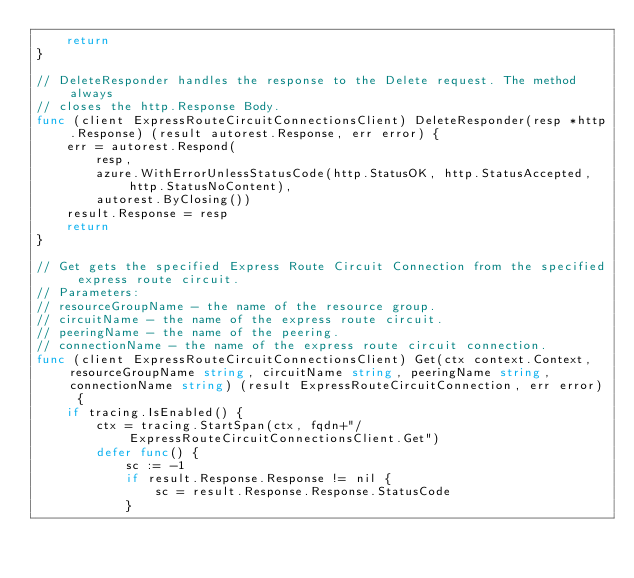Convert code to text. <code><loc_0><loc_0><loc_500><loc_500><_Go_>	return
}

// DeleteResponder handles the response to the Delete request. The method always
// closes the http.Response Body.
func (client ExpressRouteCircuitConnectionsClient) DeleteResponder(resp *http.Response) (result autorest.Response, err error) {
	err = autorest.Respond(
		resp,
		azure.WithErrorUnlessStatusCode(http.StatusOK, http.StatusAccepted, http.StatusNoContent),
		autorest.ByClosing())
	result.Response = resp
	return
}

// Get gets the specified Express Route Circuit Connection from the specified express route circuit.
// Parameters:
// resourceGroupName - the name of the resource group.
// circuitName - the name of the express route circuit.
// peeringName - the name of the peering.
// connectionName - the name of the express route circuit connection.
func (client ExpressRouteCircuitConnectionsClient) Get(ctx context.Context, resourceGroupName string, circuitName string, peeringName string, connectionName string) (result ExpressRouteCircuitConnection, err error) {
	if tracing.IsEnabled() {
		ctx = tracing.StartSpan(ctx, fqdn+"/ExpressRouteCircuitConnectionsClient.Get")
		defer func() {
			sc := -1
			if result.Response.Response != nil {
				sc = result.Response.Response.StatusCode
			}</code> 